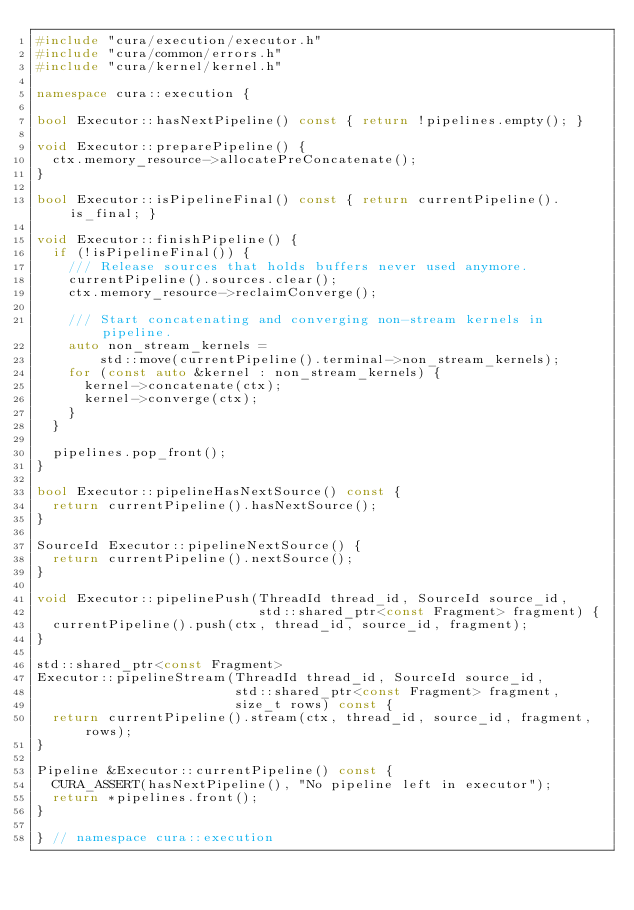Convert code to text. <code><loc_0><loc_0><loc_500><loc_500><_C++_>#include "cura/execution/executor.h"
#include "cura/common/errors.h"
#include "cura/kernel/kernel.h"

namespace cura::execution {

bool Executor::hasNextPipeline() const { return !pipelines.empty(); }

void Executor::preparePipeline() {
  ctx.memory_resource->allocatePreConcatenate();
}

bool Executor::isPipelineFinal() const { return currentPipeline().is_final; }

void Executor::finishPipeline() {
  if (!isPipelineFinal()) {
    /// Release sources that holds buffers never used anymore.
    currentPipeline().sources.clear();
    ctx.memory_resource->reclaimConverge();

    /// Start concatenating and converging non-stream kernels in pipeline.
    auto non_stream_kernels =
        std::move(currentPipeline().terminal->non_stream_kernels);
    for (const auto &kernel : non_stream_kernels) {
      kernel->concatenate(ctx);
      kernel->converge(ctx);
    }
  }

  pipelines.pop_front();
}

bool Executor::pipelineHasNextSource() const {
  return currentPipeline().hasNextSource();
}

SourceId Executor::pipelineNextSource() {
  return currentPipeline().nextSource();
}

void Executor::pipelinePush(ThreadId thread_id, SourceId source_id,
                            std::shared_ptr<const Fragment> fragment) {
  currentPipeline().push(ctx, thread_id, source_id, fragment);
}

std::shared_ptr<const Fragment>
Executor::pipelineStream(ThreadId thread_id, SourceId source_id,
                         std::shared_ptr<const Fragment> fragment,
                         size_t rows) const {
  return currentPipeline().stream(ctx, thread_id, source_id, fragment, rows);
}

Pipeline &Executor::currentPipeline() const {
  CURA_ASSERT(hasNextPipeline(), "No pipeline left in executor");
  return *pipelines.front();
}

} // namespace cura::execution
</code> 